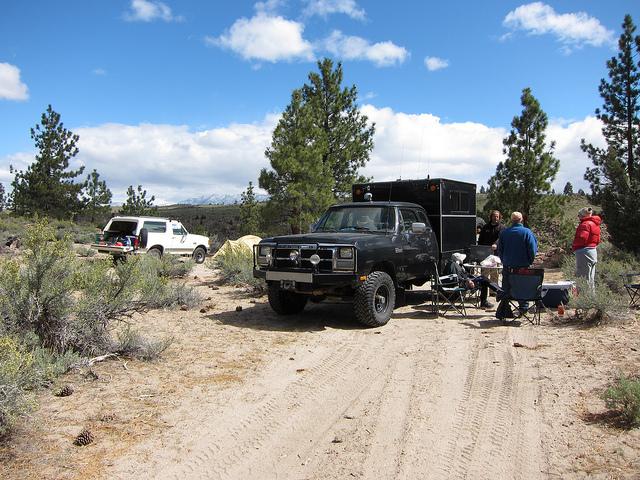How many cars are in the picture?
Be succinct. 2. Are they stuck or resting?
Keep it brief. Resting. Could you drive any of these cars?
Give a very brief answer. Yes. Is this a toy truck or a real truck?
Short answer required. Real. What is the black box behind the truck?
Be succinct. Trailer. How many vehicles are in the photo?
Be succinct. 2. 